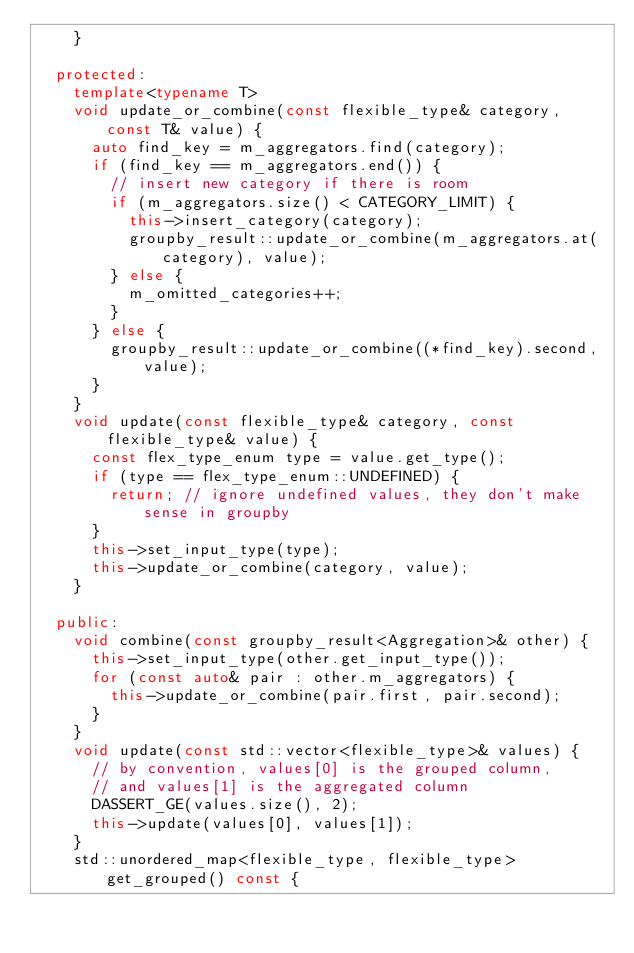Convert code to text. <code><loc_0><loc_0><loc_500><loc_500><_C++_>    }

  protected:
    template<typename T>
    void update_or_combine(const flexible_type& category, const T& value) {
      auto find_key = m_aggregators.find(category);
      if (find_key == m_aggregators.end()) {
        // insert new category if there is room
        if (m_aggregators.size() < CATEGORY_LIMIT) {
          this->insert_category(category);
          groupby_result::update_or_combine(m_aggregators.at(category), value);
        } else {
          m_omitted_categories++;
        }
      } else {
        groupby_result::update_or_combine((*find_key).second, value);
      }
    }
    void update(const flexible_type& category, const flexible_type& value) {
      const flex_type_enum type = value.get_type();
      if (type == flex_type_enum::UNDEFINED) {
        return; // ignore undefined values, they don't make sense in groupby
      }
      this->set_input_type(type);
      this->update_or_combine(category, value);
    }

  public:
    void combine(const groupby_result<Aggregation>& other) {
      this->set_input_type(other.get_input_type());
      for (const auto& pair : other.m_aggregators) {
        this->update_or_combine(pair.first, pair.second);
      }
    }
    void update(const std::vector<flexible_type>& values) {
      // by convention, values[0] is the grouped column,
      // and values[1] is the aggregated column
      DASSERT_GE(values.size(), 2);
      this->update(values[0], values[1]);
    }
    std::unordered_map<flexible_type, flexible_type> get_grouped() const {</code> 